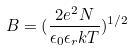Convert formula to latex. <formula><loc_0><loc_0><loc_500><loc_500>B = ( \frac { 2 e ^ { 2 } N } { \epsilon _ { 0 } \epsilon _ { r } k T } ) ^ { 1 / 2 }</formula> 